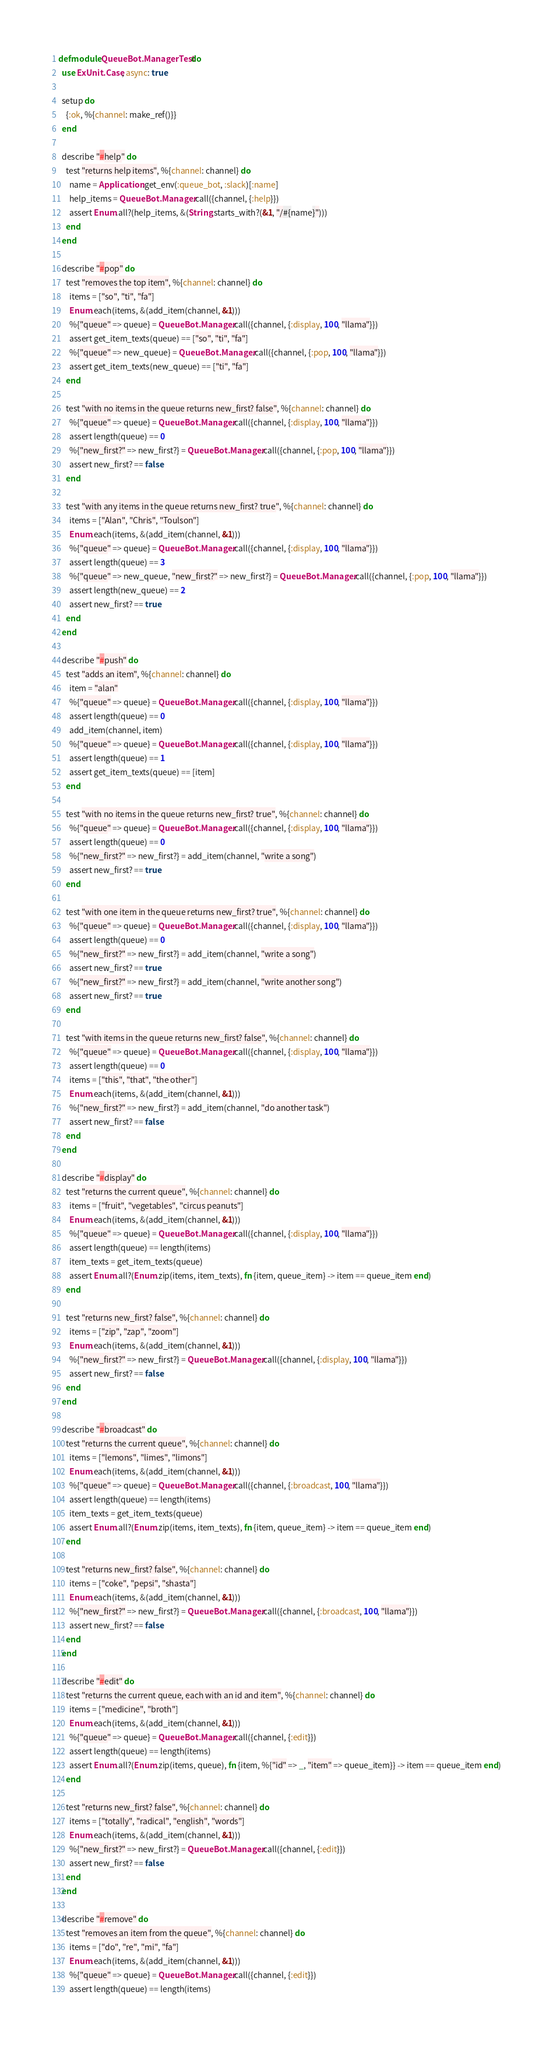<code> <loc_0><loc_0><loc_500><loc_500><_Elixir_>defmodule QueueBot.ManagerTest do
  use ExUnit.Case, async: true

  setup do
    {:ok, %{channel: make_ref()}}
  end

  describe "#help" do
    test "returns help items", %{channel: channel} do
      name = Application.get_env(:queue_bot, :slack)[:name]
      help_items = QueueBot.Manager.call({channel, {:help}})
      assert Enum.all?(help_items, &(String.starts_with?(&1, "/#{name}")))
    end
  end

  describe "#pop" do
    test "removes the top item", %{channel: channel} do
      items = ["so", "ti", "fa"]
      Enum.each(items, &(add_item(channel, &1)))
      %{"queue" => queue} = QueueBot.Manager.call({channel, {:display, 100, "llama"}})
      assert get_item_texts(queue) == ["so", "ti", "fa"]
      %{"queue" => new_queue} = QueueBot.Manager.call({channel, {:pop, 100, "llama"}})
      assert get_item_texts(new_queue) == ["ti", "fa"]
    end

    test "with no items in the queue returns new_first? false", %{channel: channel} do
      %{"queue" => queue} = QueueBot.Manager.call({channel, {:display, 100, "llama"}})
      assert length(queue) == 0
      %{"new_first?" => new_first?} = QueueBot.Manager.call({channel, {:pop, 100, "llama"}})
      assert new_first? == false
    end

    test "with any items in the queue returns new_first? true", %{channel: channel} do
      items = ["Alan", "Chris", "Toulson"]
      Enum.each(items, &(add_item(channel, &1)))
      %{"queue" => queue} = QueueBot.Manager.call({channel, {:display, 100, "llama"}})
      assert length(queue) == 3
      %{"queue" => new_queue, "new_first?" => new_first?} = QueueBot.Manager.call({channel, {:pop, 100, "llama"}})
      assert length(new_queue) == 2
      assert new_first? == true
    end
  end

  describe "#push" do
    test "adds an item", %{channel: channel} do
      item = "alan"
      %{"queue" => queue} = QueueBot.Manager.call({channel, {:display, 100, "llama"}})
      assert length(queue) == 0
      add_item(channel, item)
      %{"queue" => queue} = QueueBot.Manager.call({channel, {:display, 100, "llama"}})
      assert length(queue) == 1
      assert get_item_texts(queue) == [item]
    end

    test "with no items in the queue returns new_first? true", %{channel: channel} do
      %{"queue" => queue} = QueueBot.Manager.call({channel, {:display, 100, "llama"}})
      assert length(queue) == 0
      %{"new_first?" => new_first?} = add_item(channel, "write a song")
      assert new_first? == true
    end

    test "with one item in the queue returns new_first? true", %{channel: channel} do
      %{"queue" => queue} = QueueBot.Manager.call({channel, {:display, 100, "llama"}})
      assert length(queue) == 0
      %{"new_first?" => new_first?} = add_item(channel, "write a song")
      assert new_first? == true
      %{"new_first?" => new_first?} = add_item(channel, "write another song")
      assert new_first? == true
    end

    test "with items in the queue returns new_first? false", %{channel: channel} do
      %{"queue" => queue} = QueueBot.Manager.call({channel, {:display, 100, "llama"}})
      assert length(queue) == 0
      items = ["this", "that", "the other"]
      Enum.each(items, &(add_item(channel, &1)))
      %{"new_first?" => new_first?} = add_item(channel, "do another task")
      assert new_first? == false
    end
  end

  describe "#display" do
    test "returns the current queue", %{channel: channel} do
      items = ["fruit", "vegetables", "circus peanuts"]
      Enum.each(items, &(add_item(channel, &1)))
      %{"queue" => queue} = QueueBot.Manager.call({channel, {:display, 100, "llama"}})
      assert length(queue) == length(items)
      item_texts = get_item_texts(queue) 
      assert Enum.all?(Enum.zip(items, item_texts), fn {item, queue_item} -> item == queue_item end)
    end

    test "returns new_first? false", %{channel: channel} do
      items = ["zip", "zap", "zoom"]
      Enum.each(items, &(add_item(channel, &1)))
      %{"new_first?" => new_first?} = QueueBot.Manager.call({channel, {:display, 100, "llama"}})
      assert new_first? == false
    end
  end

  describe "#broadcast" do
    test "returns the current queue", %{channel: channel} do
      items = ["lemons", "limes", "limons"]
      Enum.each(items, &(add_item(channel, &1)))
      %{"queue" => queue} = QueueBot.Manager.call({channel, {:broadcast, 100, "llama"}})
      assert length(queue) == length(items) 
      item_texts = get_item_texts(queue) 
      assert Enum.all?(Enum.zip(items, item_texts), fn {item, queue_item} -> item == queue_item end)
    end

    test "returns new_first? false", %{channel: channel} do
      items = ["coke", "pepsi", "shasta"]
      Enum.each(items, &(add_item(channel, &1)))
      %{"new_first?" => new_first?} = QueueBot.Manager.call({channel, {:broadcast, 100, "llama"}})
      assert new_first? == false
    end
  end

  describe "#edit" do
    test "returns the current queue, each with an id and item", %{channel: channel} do
      items = ["medicine", "broth"]
      Enum.each(items, &(add_item(channel, &1)))
      %{"queue" => queue} = QueueBot.Manager.call({channel, {:edit}})
      assert length(queue) == length(items)
      assert Enum.all?(Enum.zip(items, queue), fn {item, %{"id" => _, "item" => queue_item}} -> item == queue_item end)
    end

    test "returns new_first? false", %{channel: channel} do
      items = ["totally", "radical", "english", "words"]
      Enum.each(items, &(add_item(channel, &1)))
      %{"new_first?" => new_first?} = QueueBot.Manager.call({channel, {:edit}})
      assert new_first? == false
    end
  end

  describe "#remove" do
    test "removes an item from the queue", %{channel: channel} do
      items = ["do", "re", "mi", "fa"]
      Enum.each(items, &(add_item(channel, &1)))
      %{"queue" => queue} = QueueBot.Manager.call({channel, {:edit}})
      assert length(queue) == length(items)</code> 